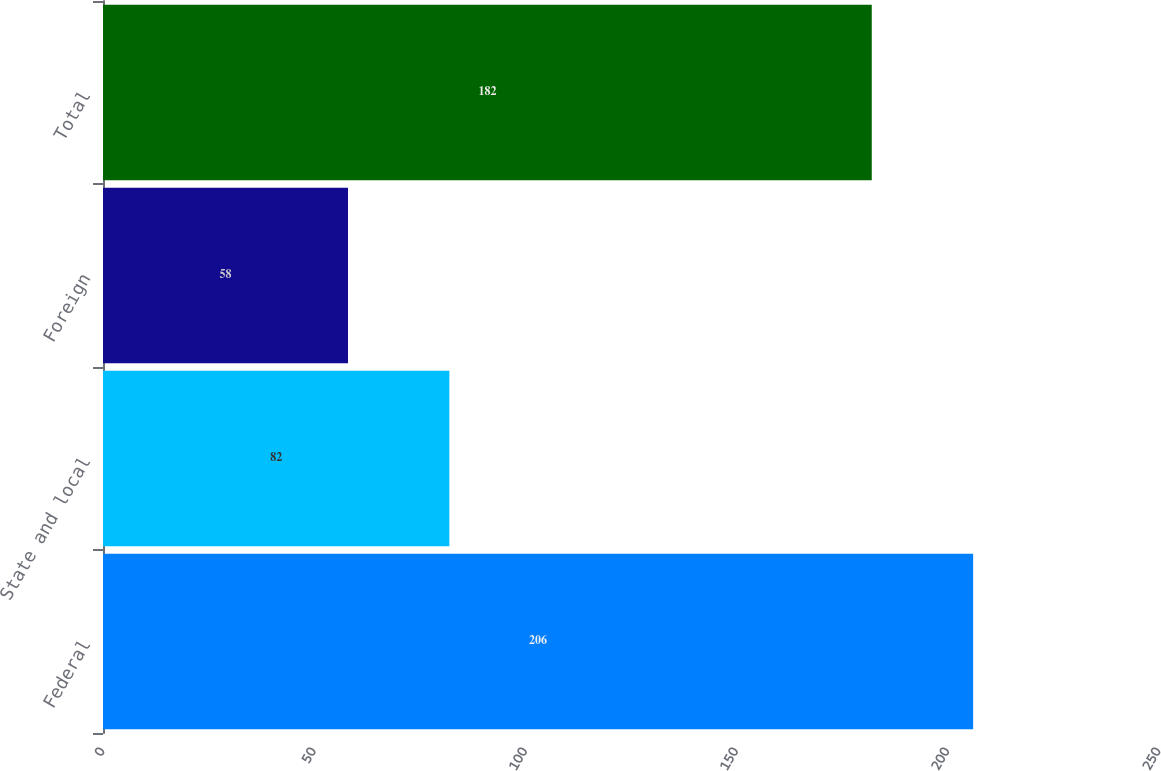Convert chart to OTSL. <chart><loc_0><loc_0><loc_500><loc_500><bar_chart><fcel>Federal<fcel>State and local<fcel>Foreign<fcel>Total<nl><fcel>206<fcel>82<fcel>58<fcel>182<nl></chart> 